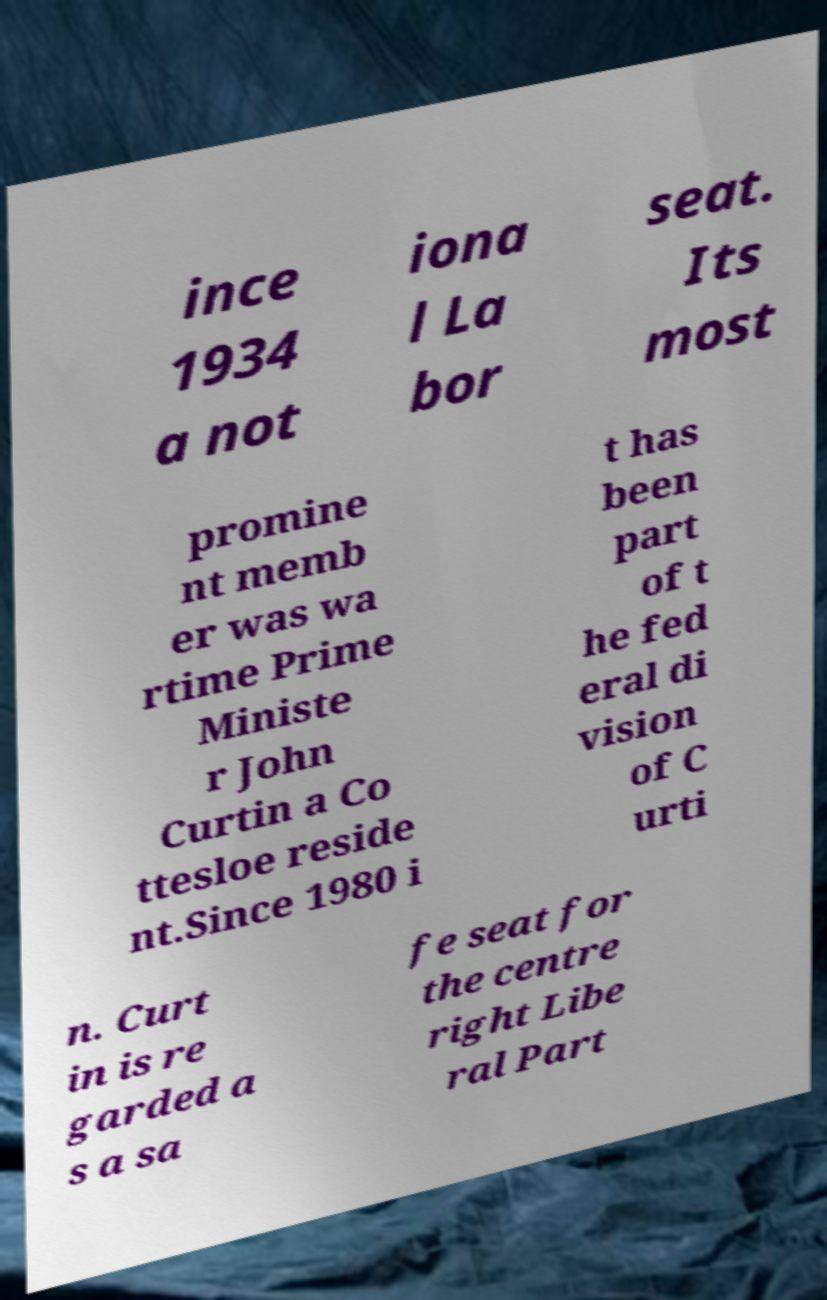For documentation purposes, I need the text within this image transcribed. Could you provide that? ince 1934 a not iona l La bor seat. Its most promine nt memb er was wa rtime Prime Ministe r John Curtin a Co ttesloe reside nt.Since 1980 i t has been part of t he fed eral di vision of C urti n. Curt in is re garded a s a sa fe seat for the centre right Libe ral Part 